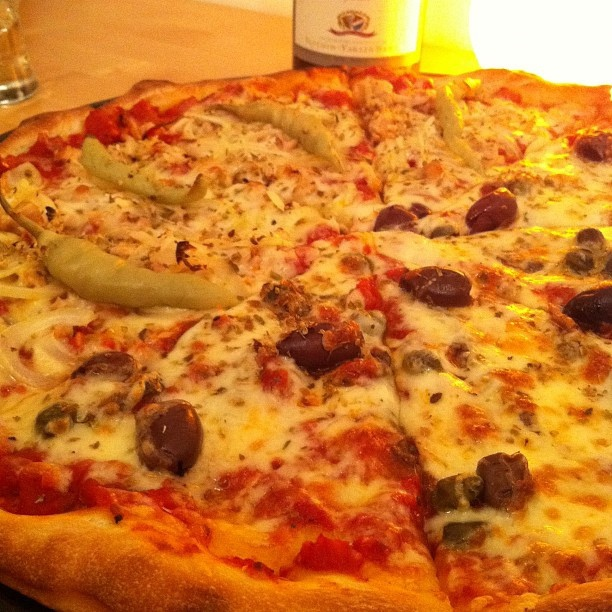Describe the objects in this image and their specific colors. I can see dining table in orange, red, and brown tones, pizza in orange, red, and brown tones, bottle in orange, brown, gold, and yellow tones, and cup in orange, red, and tan tones in this image. 